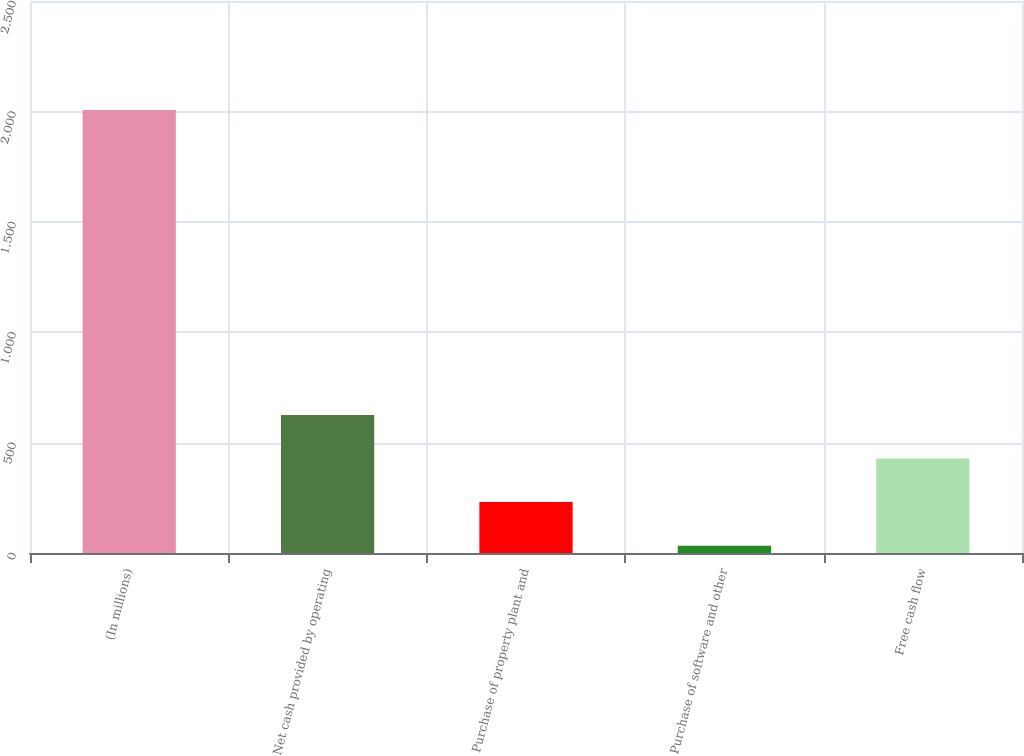<chart> <loc_0><loc_0><loc_500><loc_500><bar_chart><fcel>(In millions)<fcel>Net cash provided by operating<fcel>Purchase of property plant and<fcel>Purchase of software and other<fcel>Free cash flow<nl><fcel>2006<fcel>625.18<fcel>230.66<fcel>33.4<fcel>427.92<nl></chart> 